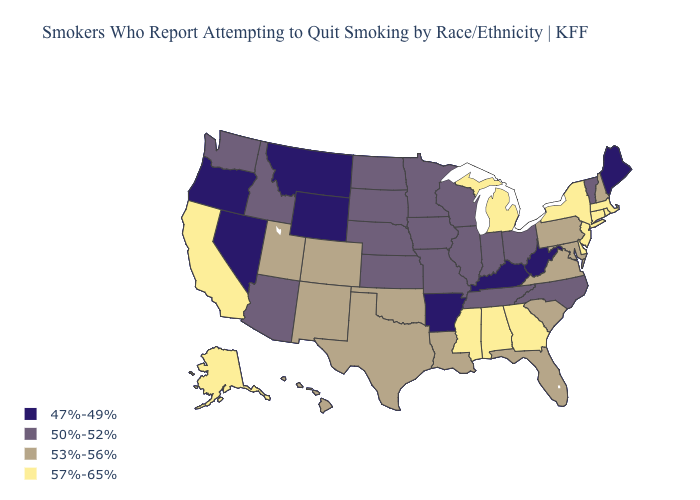Name the states that have a value in the range 57%-65%?
Write a very short answer. Alabama, Alaska, California, Connecticut, Delaware, Georgia, Massachusetts, Michigan, Mississippi, New Jersey, New York, Rhode Island. What is the value of Alabama?
Be succinct. 57%-65%. What is the highest value in the West ?
Write a very short answer. 57%-65%. Does the map have missing data?
Quick response, please. No. What is the highest value in states that border Illinois?
Keep it brief. 50%-52%. Does Arizona have a higher value than West Virginia?
Short answer required. Yes. Does the first symbol in the legend represent the smallest category?
Be succinct. Yes. Which states have the lowest value in the USA?
Give a very brief answer. Arkansas, Kentucky, Maine, Montana, Nevada, Oregon, West Virginia, Wyoming. What is the highest value in the USA?
Give a very brief answer. 57%-65%. Which states have the lowest value in the West?
Give a very brief answer. Montana, Nevada, Oregon, Wyoming. Which states hav the highest value in the Northeast?
Be succinct. Connecticut, Massachusetts, New Jersey, New York, Rhode Island. Does Wyoming have the lowest value in the USA?
Write a very short answer. Yes. Does Nebraska have the lowest value in the USA?
Be succinct. No. What is the value of Oregon?
Keep it brief. 47%-49%. 